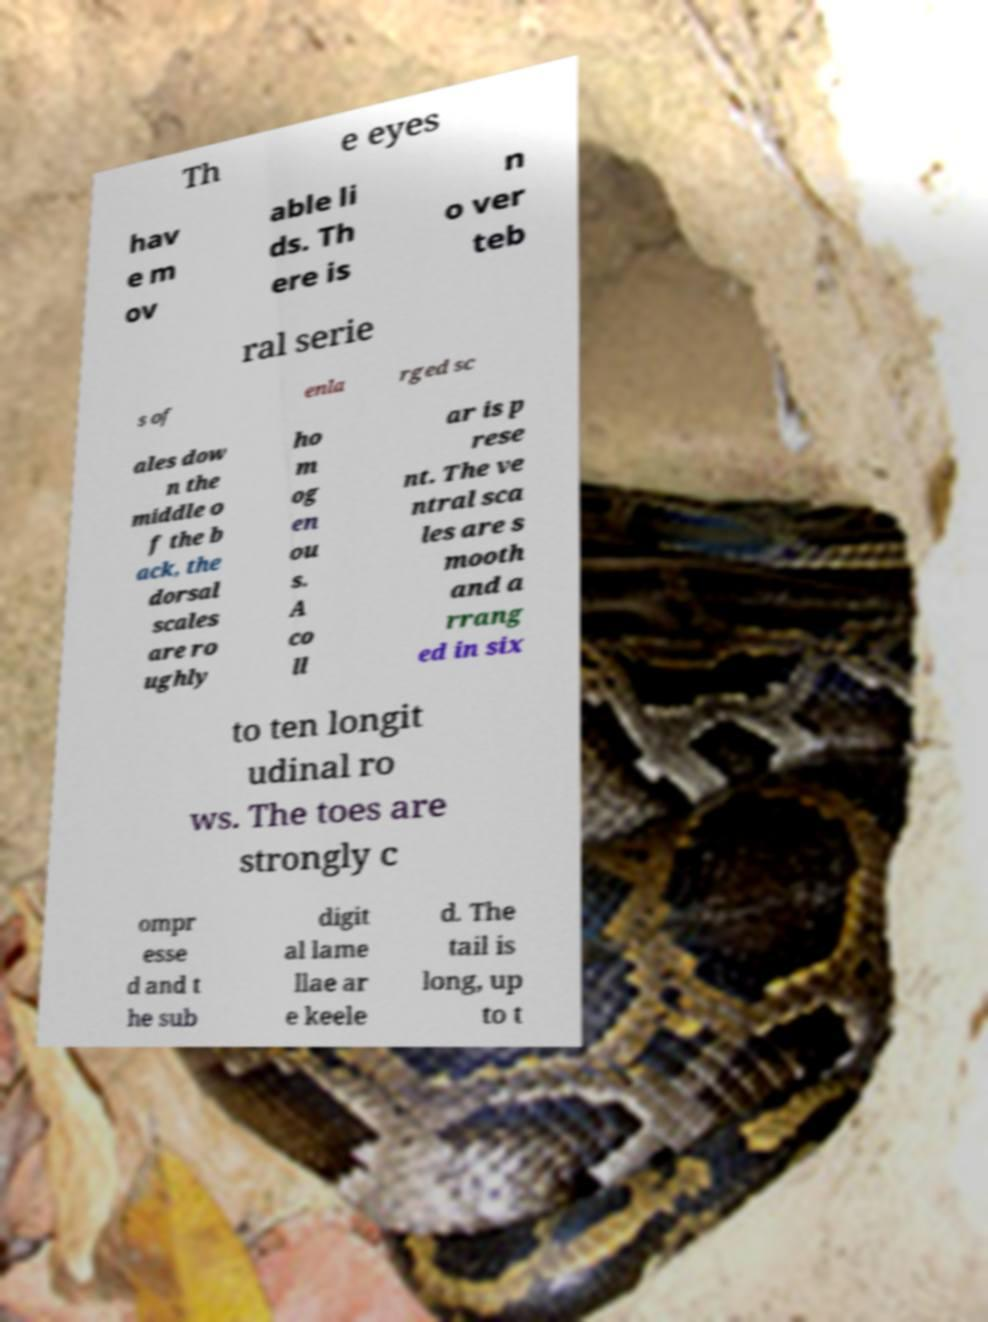Please identify and transcribe the text found in this image. Th e eyes hav e m ov able li ds. Th ere is n o ver teb ral serie s of enla rged sc ales dow n the middle o f the b ack, the dorsal scales are ro ughly ho m og en ou s. A co ll ar is p rese nt. The ve ntral sca les are s mooth and a rrang ed in six to ten longit udinal ro ws. The toes are strongly c ompr esse d and t he sub digit al lame llae ar e keele d. The tail is long, up to t 